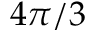Convert formula to latex. <formula><loc_0><loc_0><loc_500><loc_500>4 \pi / 3</formula> 